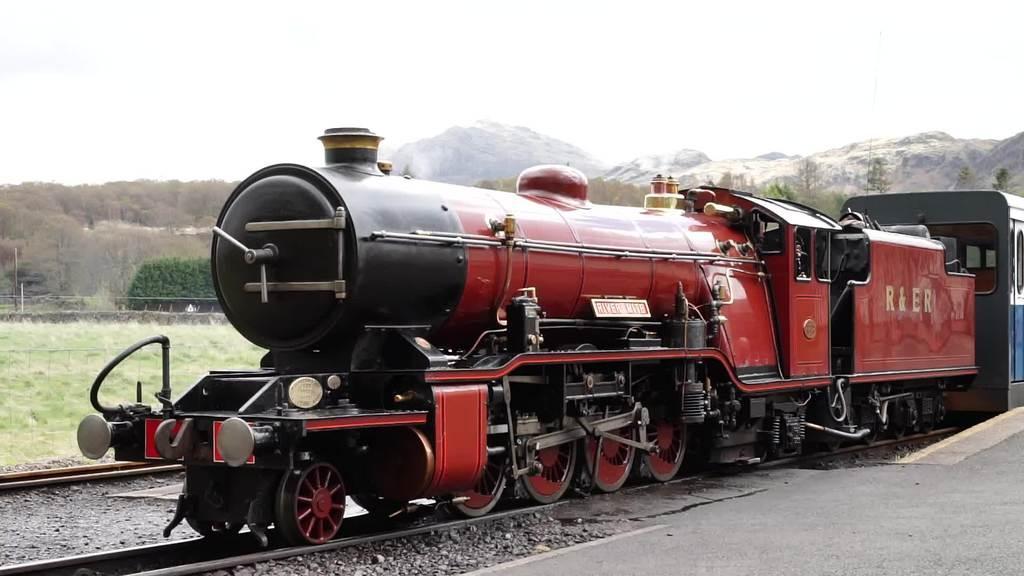Describe this image in one or two sentences. Here in this picture we can see a train present on a railway track over there and beside that the ground is covered with grass and we can see bushes, plants and trees all over there and behind that in the far we can see mountains that are covered with snow over there. 